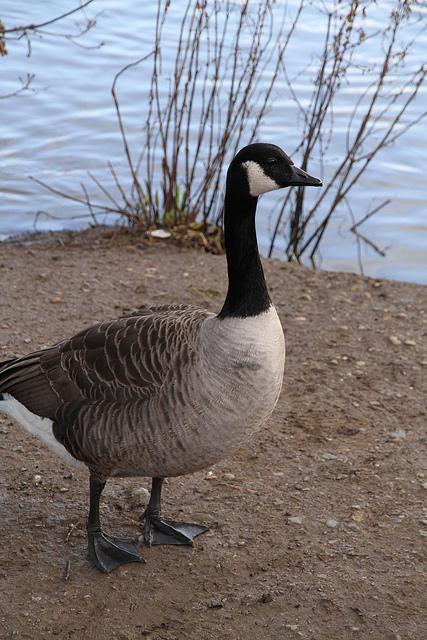How many adult geese?
Give a very brief answer. 1. How many legs is the bird perched on?
Give a very brief answer. 2. 